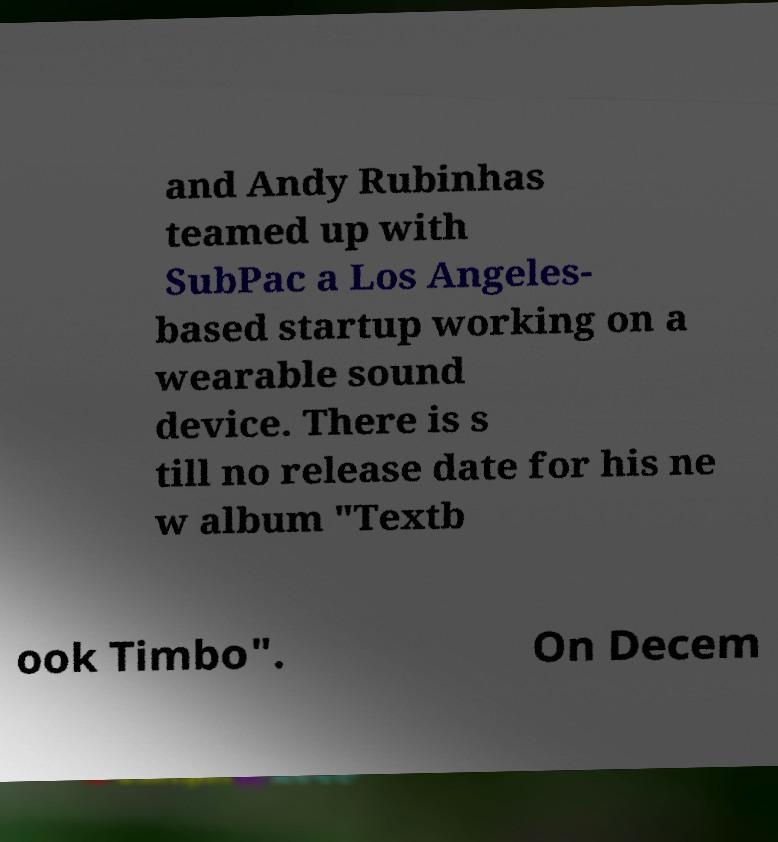What messages or text are displayed in this image? I need them in a readable, typed format. and Andy Rubinhas teamed up with SubPac a Los Angeles- based startup working on a wearable sound device. There is s till no release date for his ne w album "Textb ook Timbo". On Decem 